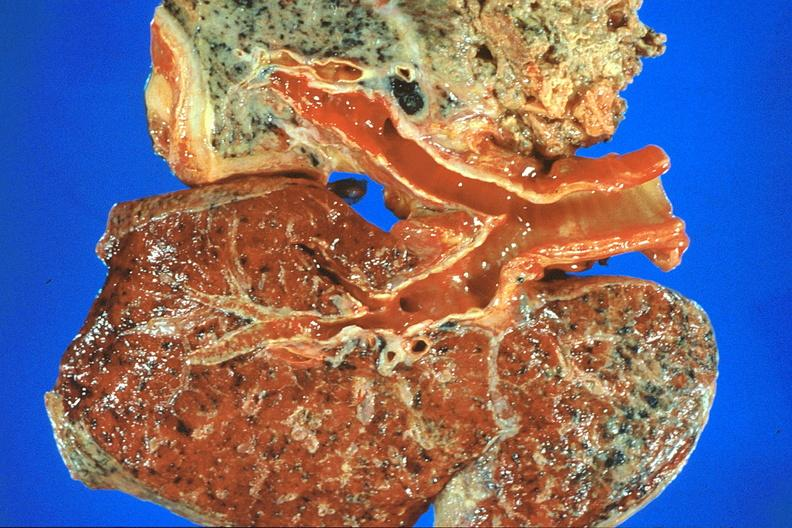does this image show lung, asbestosis and mesothelioma?
Answer the question using a single word or phrase. Yes 